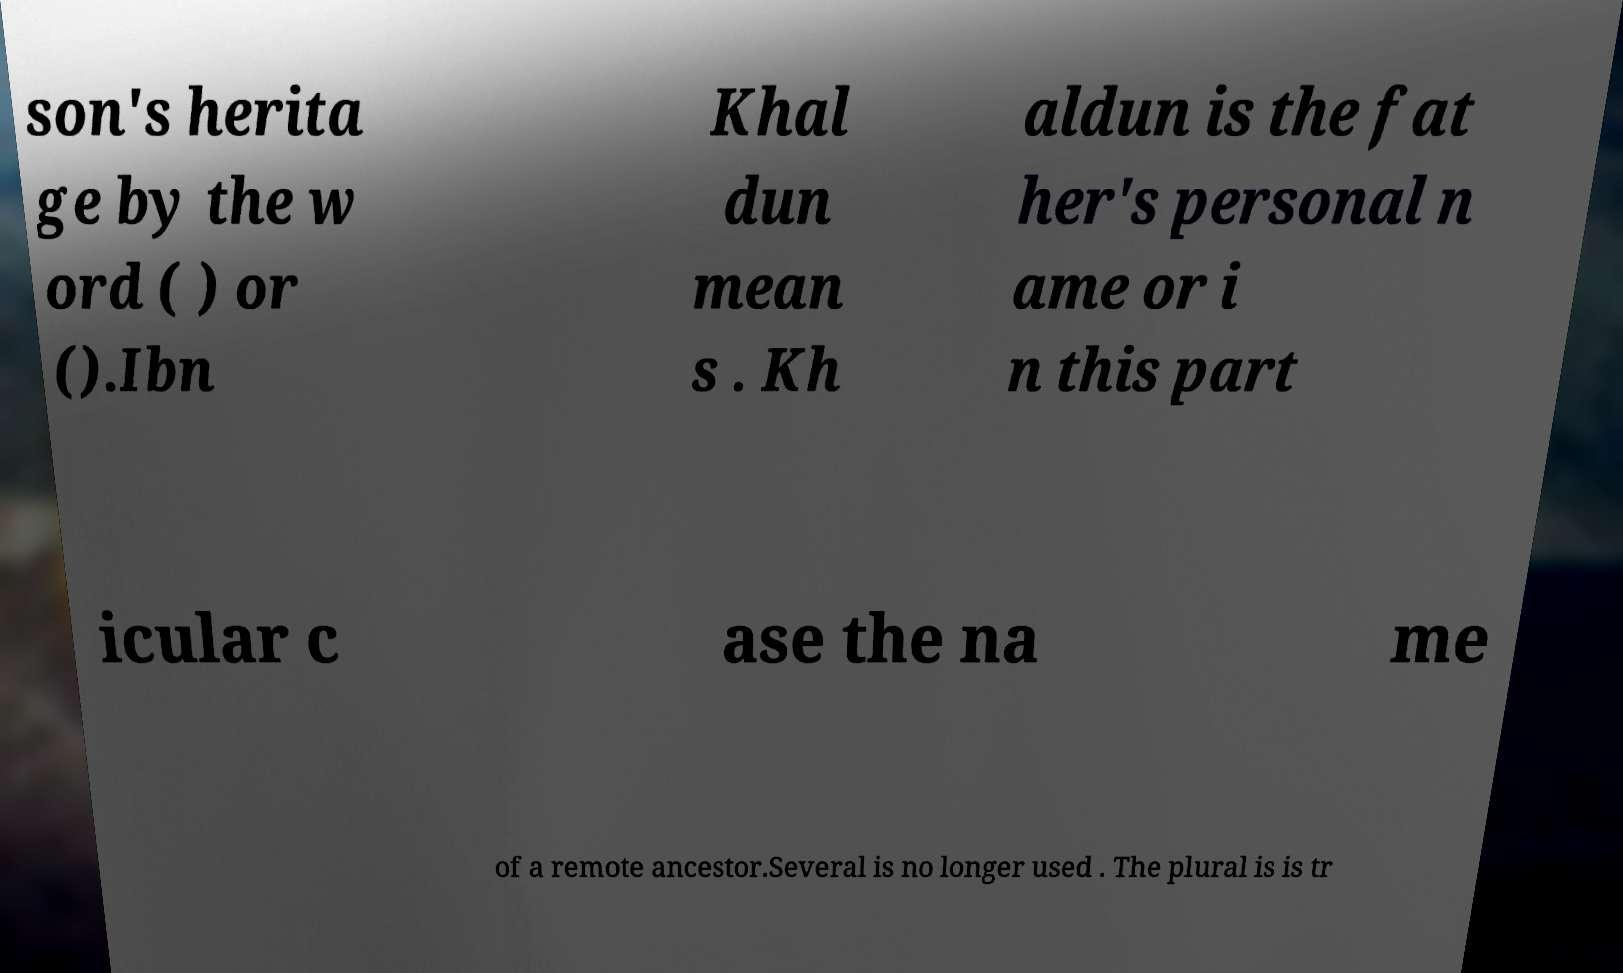What messages or text are displayed in this image? I need them in a readable, typed format. son's herita ge by the w ord ( ) or ().Ibn Khal dun mean s . Kh aldun is the fat her's personal n ame or i n this part icular c ase the na me of a remote ancestor.Several is no longer used . The plural is is tr 